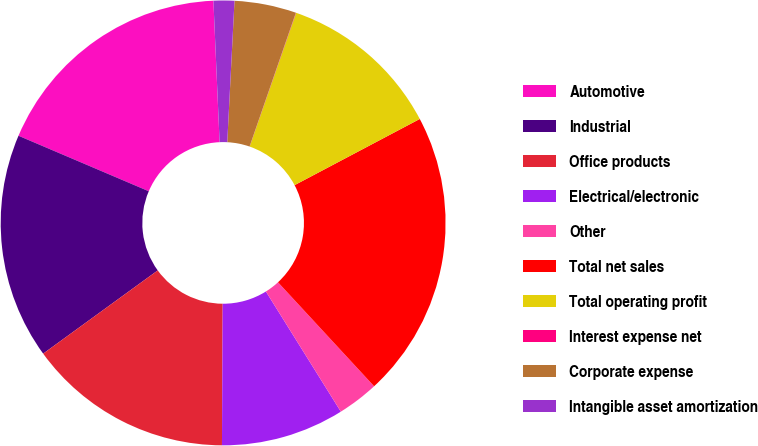Convert chart. <chart><loc_0><loc_0><loc_500><loc_500><pie_chart><fcel>Automotive<fcel>Industrial<fcel>Office products<fcel>Electrical/electronic<fcel>Other<fcel>Total net sales<fcel>Total operating profit<fcel>Interest expense net<fcel>Corporate expense<fcel>Intangible asset amortization<nl><fcel>17.9%<fcel>16.41%<fcel>14.92%<fcel>8.96%<fcel>3.0%<fcel>20.87%<fcel>11.94%<fcel>0.02%<fcel>4.49%<fcel>1.51%<nl></chart> 